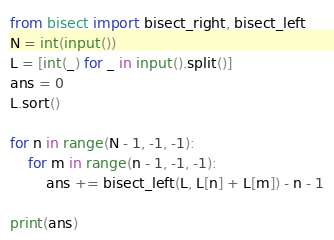Convert code to text. <code><loc_0><loc_0><loc_500><loc_500><_Python_>from bisect import bisect_right, bisect_left
N = int(input())
L = [int(_) for _ in input().split()]
ans = 0
L.sort()

for n in range(N - 1, -1, -1):
    for m in range(n - 1, -1, -1):
        ans += bisect_left(L, L[n] + L[m]) - n - 1

print(ans)</code> 